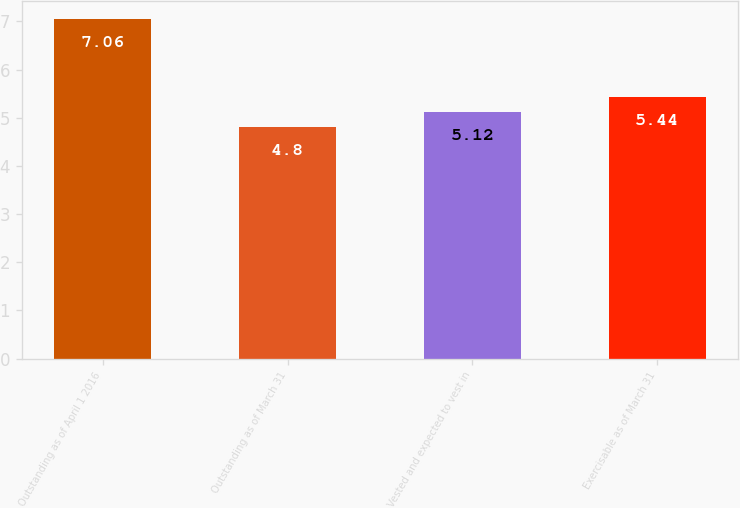Convert chart to OTSL. <chart><loc_0><loc_0><loc_500><loc_500><bar_chart><fcel>Outstanding as of April 1 2016<fcel>Outstanding as of March 31<fcel>Vested and expected to vest in<fcel>Exercisable as of March 31<nl><fcel>7.06<fcel>4.8<fcel>5.12<fcel>5.44<nl></chart> 